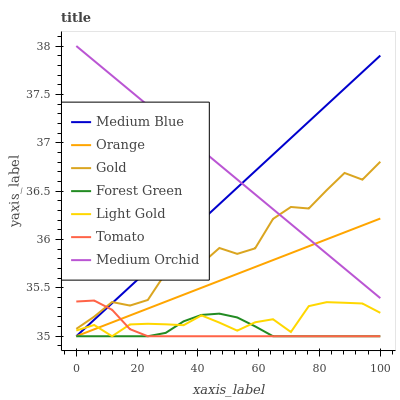Does Tomato have the minimum area under the curve?
Answer yes or no. Yes. Does Medium Orchid have the maximum area under the curve?
Answer yes or no. Yes. Does Gold have the minimum area under the curve?
Answer yes or no. No. Does Gold have the maximum area under the curve?
Answer yes or no. No. Is Medium Blue the smoothest?
Answer yes or no. Yes. Is Gold the roughest?
Answer yes or no. Yes. Is Medium Orchid the smoothest?
Answer yes or no. No. Is Medium Orchid the roughest?
Answer yes or no. No. Does Tomato have the lowest value?
Answer yes or no. Yes. Does Gold have the lowest value?
Answer yes or no. No. Does Medium Orchid have the highest value?
Answer yes or no. Yes. Does Gold have the highest value?
Answer yes or no. No. Is Orange less than Gold?
Answer yes or no. Yes. Is Medium Orchid greater than Light Gold?
Answer yes or no. Yes. Does Tomato intersect Orange?
Answer yes or no. Yes. Is Tomato less than Orange?
Answer yes or no. No. Is Tomato greater than Orange?
Answer yes or no. No. Does Orange intersect Gold?
Answer yes or no. No. 